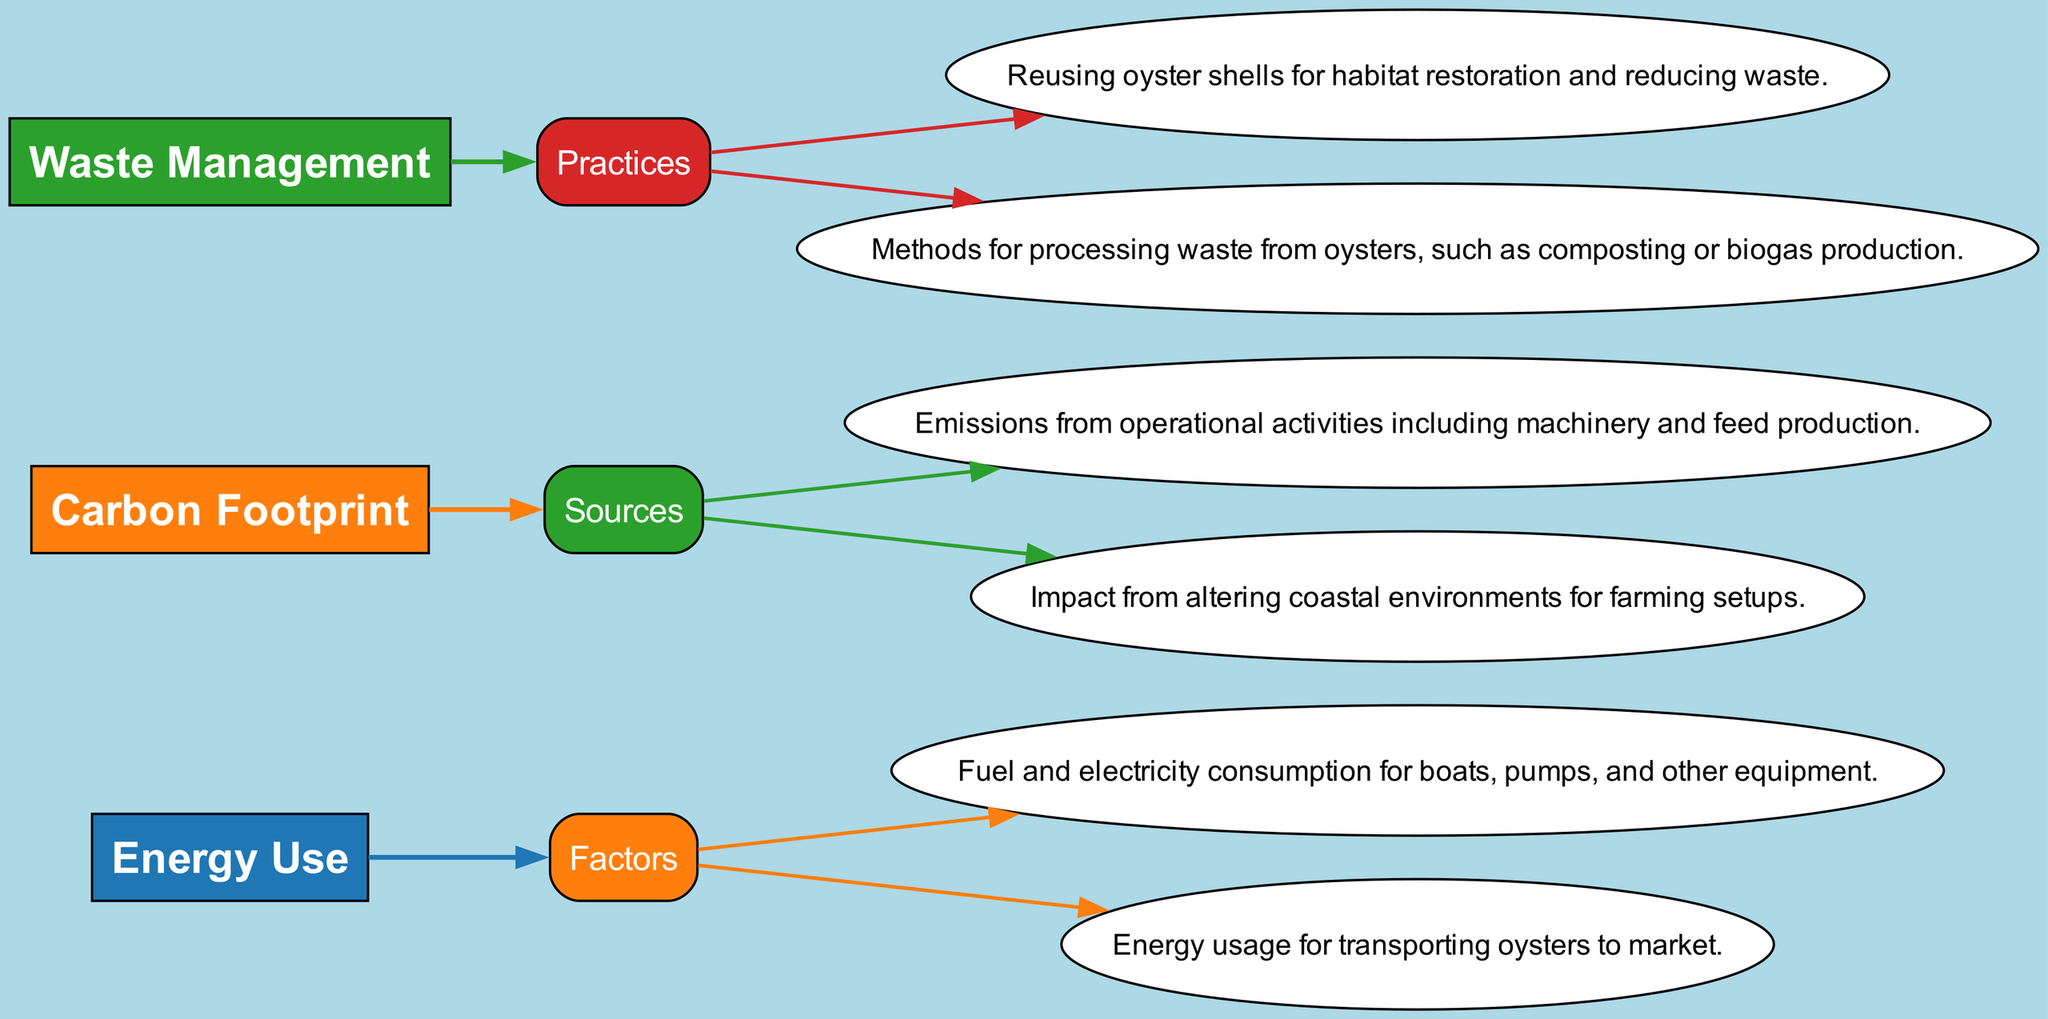What are the two main categories related to energy use in the diagram? The diagram indicates that the two main categories related to energy use are "Farming Equipment" and "Transportation", both of which are connected to the "Energy Use" node.
Answer: Farming Equipment, Transportation How many subcategories are under "Carbon Footprint"? The "Carbon Footprint" category has two subcategories listed: "Aquaculture Operations" and "Land Use Change". Hence, the total number of subcategories is two.
Answer: 2 Which practice in waste management is focused on habitat restoration? The practice responsible for habitat restoration in waste management is "Shell Recycling", as indicated in the "Waste Management" section of the diagram.
Answer: Shell Recycling What description is associated with "Transportation"? "Transportation" is described as "Energy usage for transporting oysters to market" in the diagram. This summary is directly connected to the "Transportation" subcategory under "Energy Use".
Answer: Energy usage for transporting oysters to market Which node is connected to both "Aquaculture Operations" and "Land Use Change"? The node that connects to both "Aquaculture Operations" and "Land Use Change" is "Carbon Footprint", as both sources of emissions are subcategories under this main category.
Answer: Carbon Footprint What practice is described as "Methods for processing waste from oysters"? The practice described as such is "Organic Waste Treatment", which outlines the methods employed to handle waste produced by oysters, including composting and biogas production.
Answer: Organic Waste Treatment Which category includes the description related to "Fuel and electricity consumption for boats"? The description related to "Fuel and electricity consumption for boats" is under the "Farming Equipment" subcategory within the "Energy Use" category. Thus, it directly falls under energy use considerations.
Answer: Energy Use Are there more factors under "Energy Use" than practices under "Waste Management"? "Energy Use" has two factors: "Farming Equipment" and "Transportation". In contrast, "Waste Management" has two practices: "Shell Recycling" and "Organic Waste Treatment". Since both counts are equal, the answer is 'no'.
Answer: No How is "Shell Recycling" related to waste management sustainability? "Shell Recycling" is aimed at reusing oyster shells which lessens waste and contributes positively to environmental sustainability, as it involves repurposing materials instead of discarding them.
Answer: Habitat restoration and waste reduction 